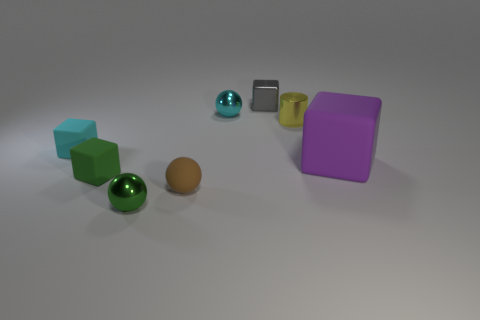Add 2 tiny cubes. How many objects exist? 10 Subtract all tiny shiny balls. How many balls are left? 1 Subtract all gray cubes. How many cubes are left? 3 Subtract all balls. How many objects are left? 5 Add 3 small green matte things. How many small green matte things exist? 4 Subtract 0 purple cylinders. How many objects are left? 8 Subtract 3 blocks. How many blocks are left? 1 Subtract all brown cylinders. Subtract all blue spheres. How many cylinders are left? 1 Subtract all big purple metallic objects. Subtract all small green rubber things. How many objects are left? 7 Add 2 small cyan matte blocks. How many small cyan matte blocks are left? 3 